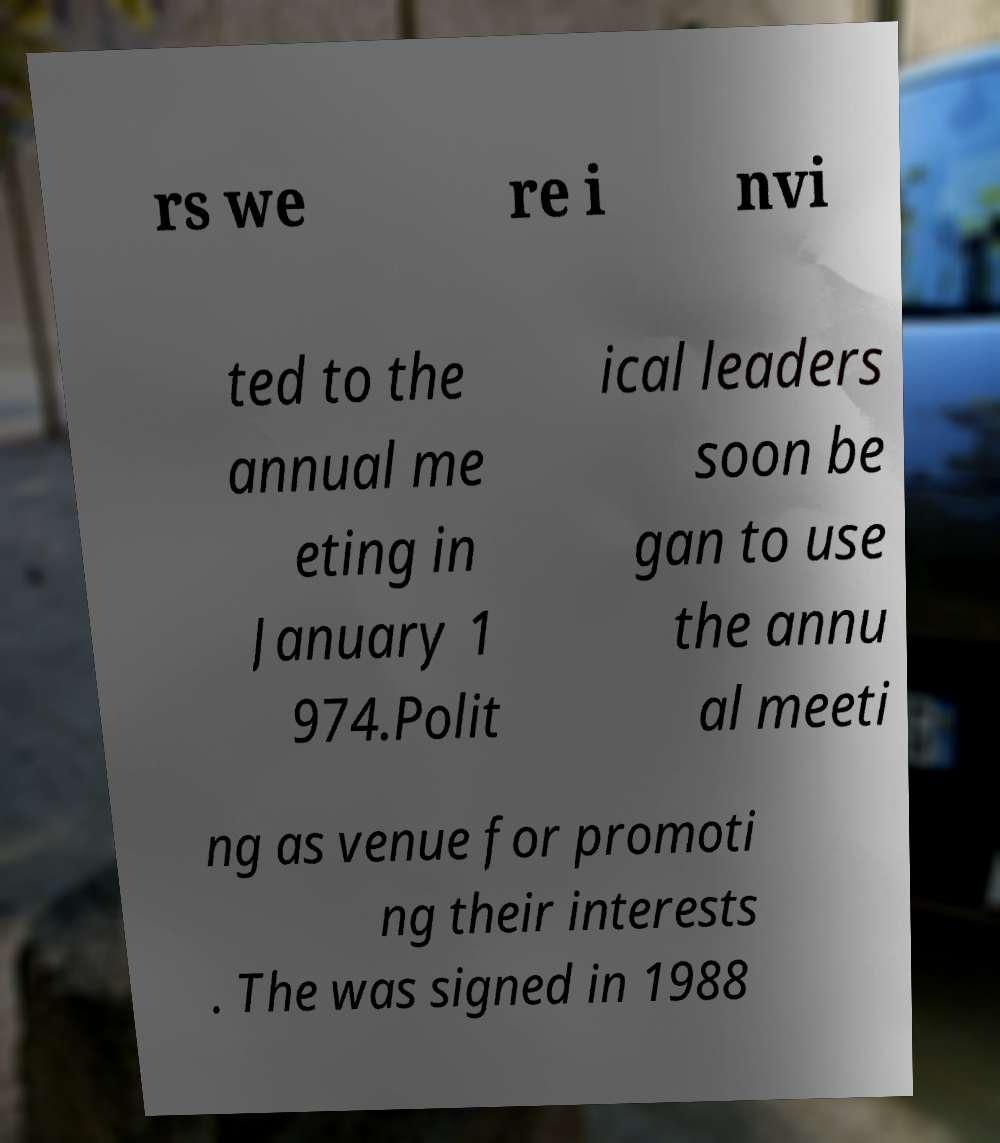For documentation purposes, I need the text within this image transcribed. Could you provide that? rs we re i nvi ted to the annual me eting in January 1 974.Polit ical leaders soon be gan to use the annu al meeti ng as venue for promoti ng their interests . The was signed in 1988 